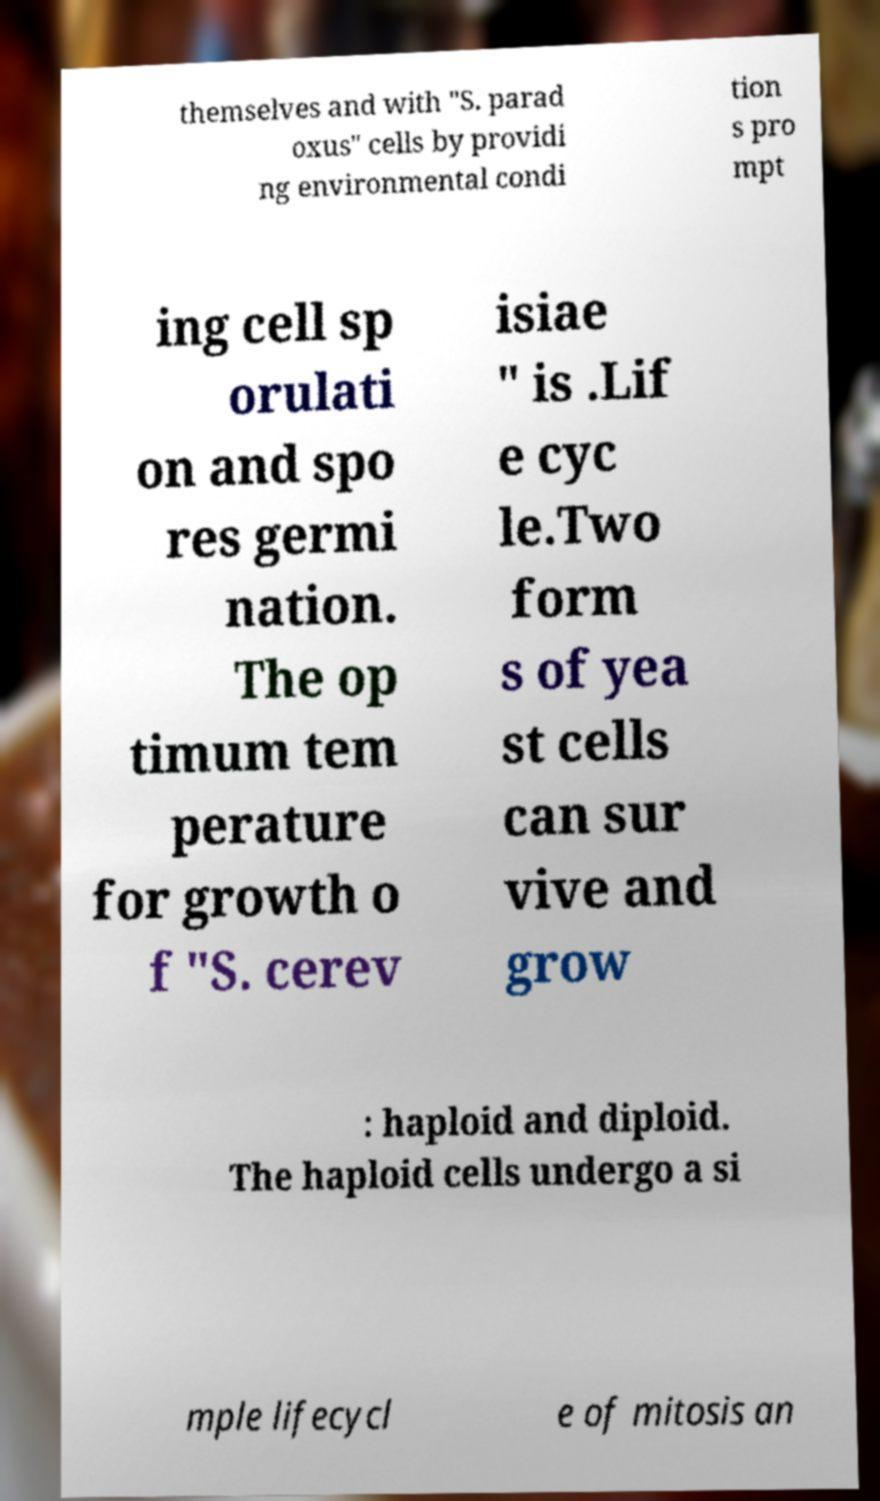For documentation purposes, I need the text within this image transcribed. Could you provide that? themselves and with "S. parad oxus" cells by providi ng environmental condi tion s pro mpt ing cell sp orulati on and spo res germi nation. The op timum tem perature for growth o f "S. cerev isiae " is .Lif e cyc le.Two form s of yea st cells can sur vive and grow : haploid and diploid. The haploid cells undergo a si mple lifecycl e of mitosis an 